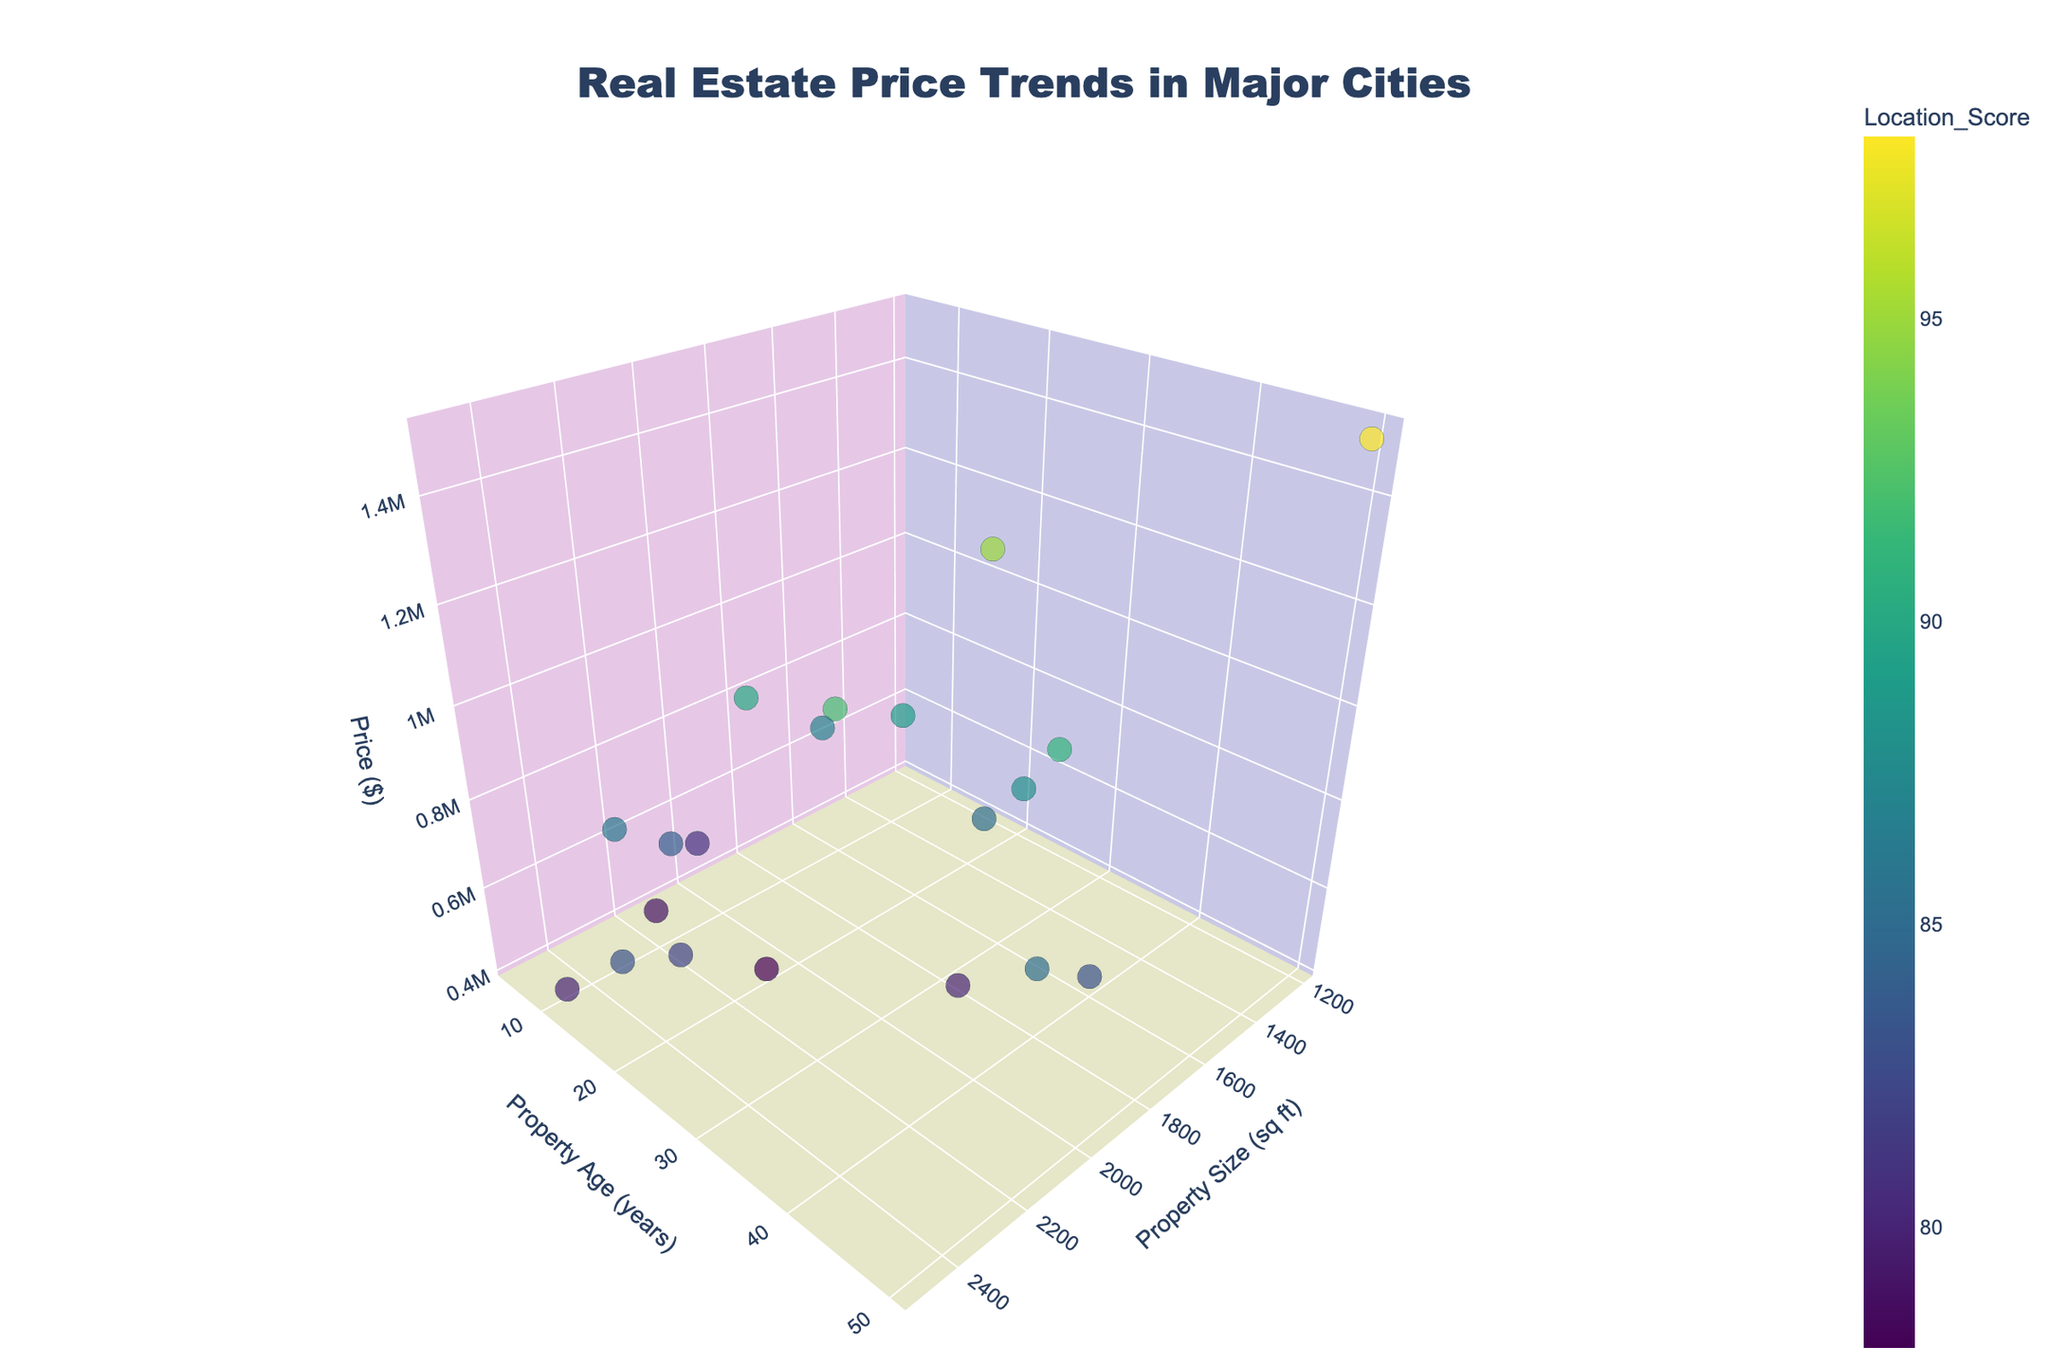What city has the highest property price, and what is the price? To find the city with the highest property price, look at the vertical axis (Price) and identify the highest data point. Check the hover label for the corresponding city.
Answer: San Francisco, $1,500,000 Which city has the largest property size, and what is the size? Look at the horizontal axis (Property Size) to identify the furthest data point to the right. Check the hover label for the respective city.
Answer: Houston, 2500 sq ft How does property age affect prices in this dataset? To analyze the effect of property age on prices, observe how data points are distributed along the age axis (Y-axis) and compare their vertical positions (Price axis). Older properties do not necessarily have lower prices; for example, San Francisco has the highest price but is also one of the oldest properties.
Answer: No direct correlation Which city has the highest location score, and what is it? Look at the color gradient of the data points representing the location score and identify the city with the brightest color. Check the hover label for the city and location score.
Answer: San Francisco, 98 What is the relationship between property size and price in this dataset? Examine the distribution of data points along the Property Size (X-axis) and Price (Z-axis). Generally, larger properties do not always equate to higher prices; for example, San Francisco has a smaller property size but the highest price.
Answer: No clear pattern Compare the property prices of New York and Los Angeles. Which is higher and by how much? Locate the data points for New York and Los Angeles using the hover labels. Check the prices and calculate the difference. New York price: $1,200,000, Los Angeles price: $950,000.
Answer: New York, $250,000 higher Which city has the lowest property price, and what is the amount? Look at the vertical axis (Price) and identify the lowest data point. Check the hover label for the city and its price.
Answer: Las Vegas, $420,000 Compare Boston's property size and age with Seattle's. Which city has older properties and which has larger properties? Locate the data points for Boston and Seattle using the hover labels. Compare their property sizes (X-axis) and ages (Y-axis). Boston has an age of 35 years and size of 1700 sq ft, Seattle has an age of 20 years and size of 1900 sq ft.
Answer: Boston older, Seattle larger Is there a general trend between location score and price? Look at the color gradient (representing location score) of the data points and compare their vertical positions (Price). Higher location scores often correlate with higher prices; for example, San Francisco has both high price and location score.
Answer: Positive correlation between high location score and high price Identify the city with a mix of high size, young age, and moderate price. Find a data point with a large X value (Property Size), low Y value (Age), and moderate Z value (Price). Denver fits this description with 2200 sq ft size, 5 years age, and $620,000 price.
Answer: Denver 